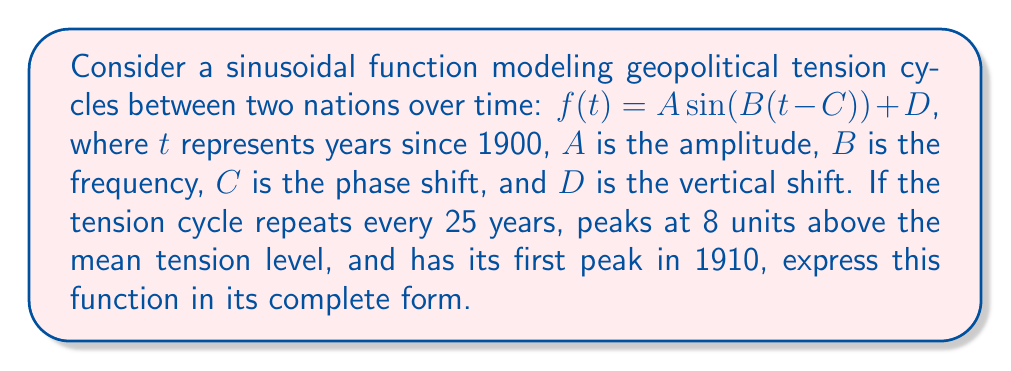Solve this math problem. 1. Determine the frequency $B$:
   The period is 25 years, so $B = \frac{2\pi}{\text{period}} = \frac{2\pi}{25}$

2. Determine the amplitude $A$:
   The peak is 8 units above the mean, so $A = 8$

3. Determine the phase shift $C$:
   The first peak occurs in 1910, which is 10 years after 1900.
   For a sine function, the peak occurs at $\frac{\pi}{2}$ in its cycle.
   Solve: $B(10-C) = \frac{\pi}{2}$
   $\frac{2\pi}{25}(10-C) = \frac{\pi}{2}$
   $10-C = \frac{25}{4}$
   $C = 10 - \frac{25}{4} = -\frac{5}{4}$

4. Determine the vertical shift $D$:
   The function oscillates around the mean tension level, so $D = 0$

5. Combine all parts into the final function:
   $f(t) = 8 \sin(\frac{2\pi}{25}(t+\frac{5}{4})) + 0$
Answer: $f(t) = 8 \sin(\frac{2\pi}{25}(t+\frac{5}{4}))$ 